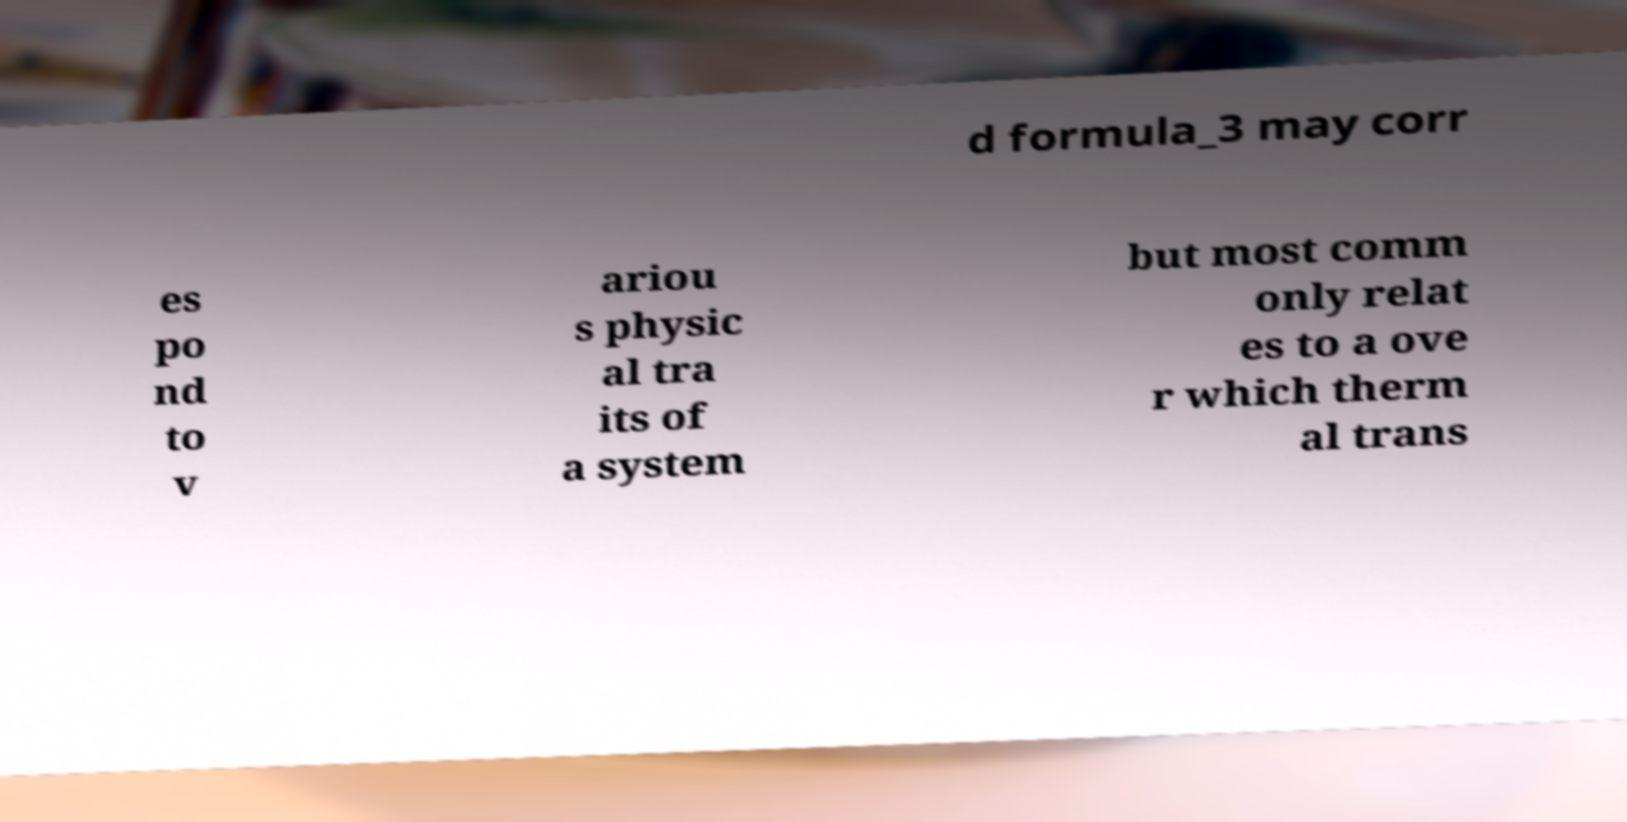Please read and relay the text visible in this image. What does it say? d formula_3 may corr es po nd to v ariou s physic al tra its of a system but most comm only relat es to a ove r which therm al trans 